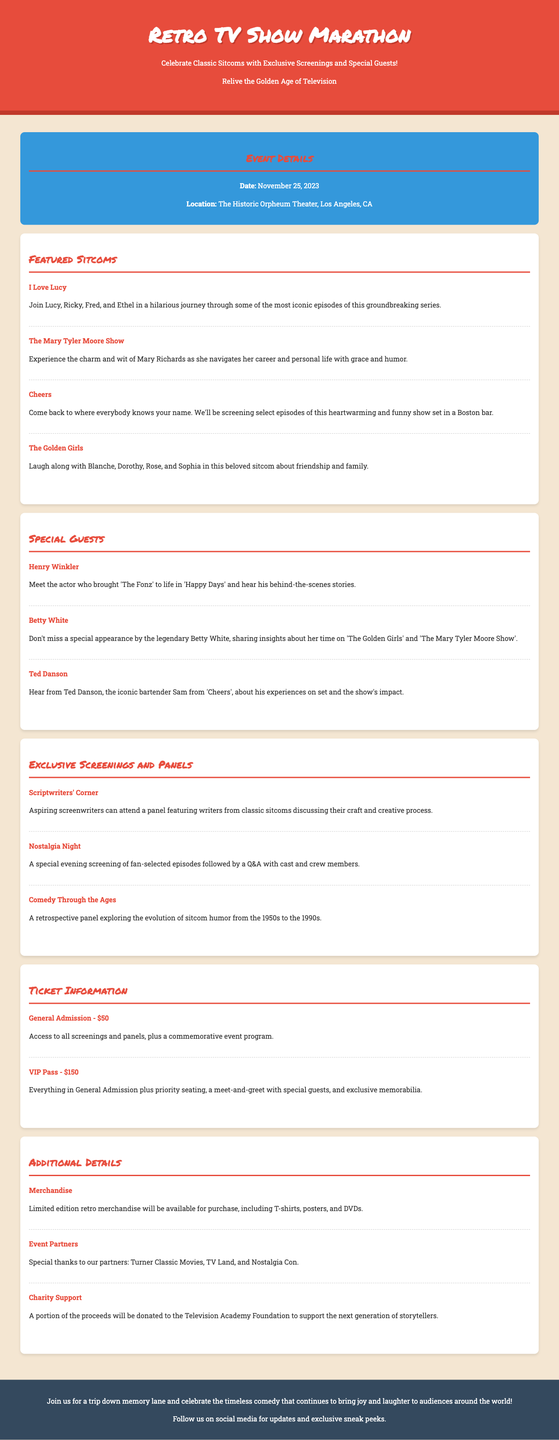What is the date of the event? The document specifies the date of the event as November 25, 2023.
Answer: November 25, 2023 Where will the event take place? The advertisement states the location of the event as The Historic Orpheum Theater, Los Angeles, CA.
Answer: The Historic Orpheum Theater, Los Angeles, CA Who is a special guest at the event? The document lists several special guests, one of which is Henry Winkler, who is mentioned in the special guests section.
Answer: Henry Winkler What is the price of a VIP Pass? The advertisement outlines the price of a VIP Pass as $150 in the ticket information section.
Answer: $150 Which sitcom features characters Lucy, Ricky, Fred, and Ethel? The featured shows section describes the sitcom "I Love Lucy" with characters Lucy, Ricky, Fred, and Ethel.
Answer: I Love Lucy What is included with General Admission tickets? The document specifies that General Admission includes access to all screenings and panels, plus a commemorative event program.
Answer: Access to all screenings and panels, plus a commemorative event program What panel discusses the evolution of sitcom humor? The sessions include "Comedy Through the Ages," which discusses the evolution of sitcom humor.
Answer: Comedy Through the Ages What portion of the proceeds will be donated to charity? The document mentions that a portion of the proceeds will be donated to the Television Academy Foundation.
Answer: To the Television Academy Foundation 